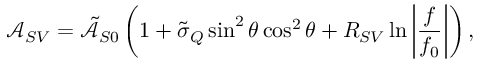Convert formula to latex. <formula><loc_0><loc_0><loc_500><loc_500>\mathcal { A } _ { S V } = \tilde { \mathcal { A } } _ { S 0 } \left ( 1 + \tilde { \sigma } _ { Q } \sin ^ { 2 } \theta \cos ^ { 2 } \theta + R _ { S V } \ln { \left | \frac { f } { f _ { 0 } } \right | } \right ) ,</formula> 